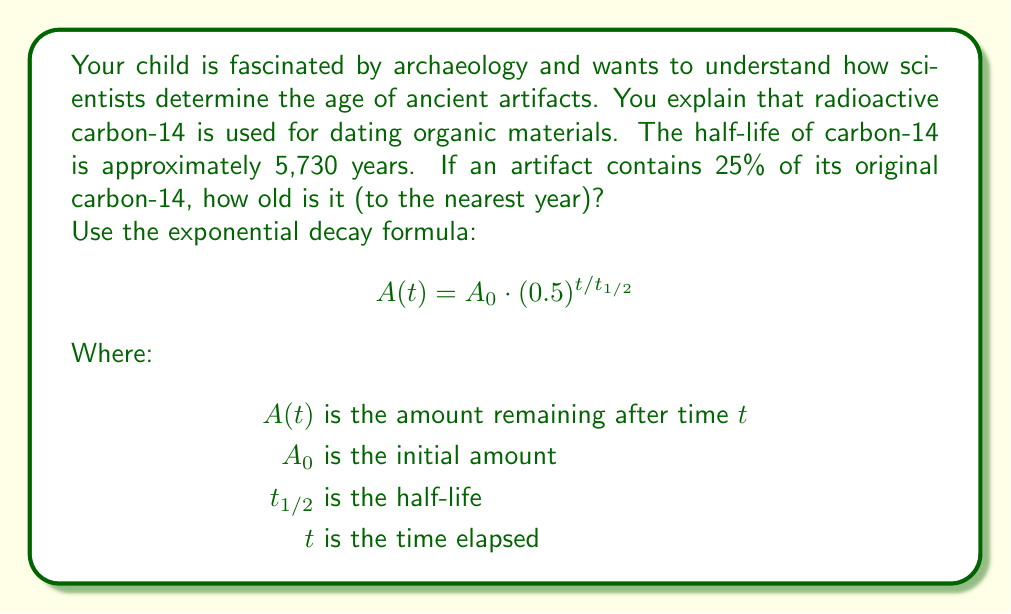Give your solution to this math problem. Let's approach this step-by-step:

1) We know that 25% of the original carbon-14 remains. This means:
   $A(t) = 0.25A_0$

2) We can substitute this into our formula:
   $$0.25A_0 = A_0 \cdot (0.5)^{t/5730}$$

3) The $A_0$ cancels out on both sides:
   $$0.25 = (0.5)^{t/5730}$$

4) Now, we can take the logarithm (base 2) of both sides:
   $$\log_2(0.25) = \log_2((0.5)^{t/5730})$$

5) Using the logarithm property $\log_a(x^n) = n\log_a(x)$:
   $$\log_2(0.25) = \frac{t}{5730} \log_2(0.5)$$

6) We know that $\log_2(0.5) = -1$ and $\log_2(0.25) = -2$, so:
   $$-2 = \frac{t}{5730} \cdot (-1)$$

7) Simplify:
   $$2 = \frac{t}{5730}$$

8) Solve for $t$:
   $$t = 2 \cdot 5730 = 11,460$$

Therefore, the artifact is approximately 11,460 years old.
Answer: 11,460 years 